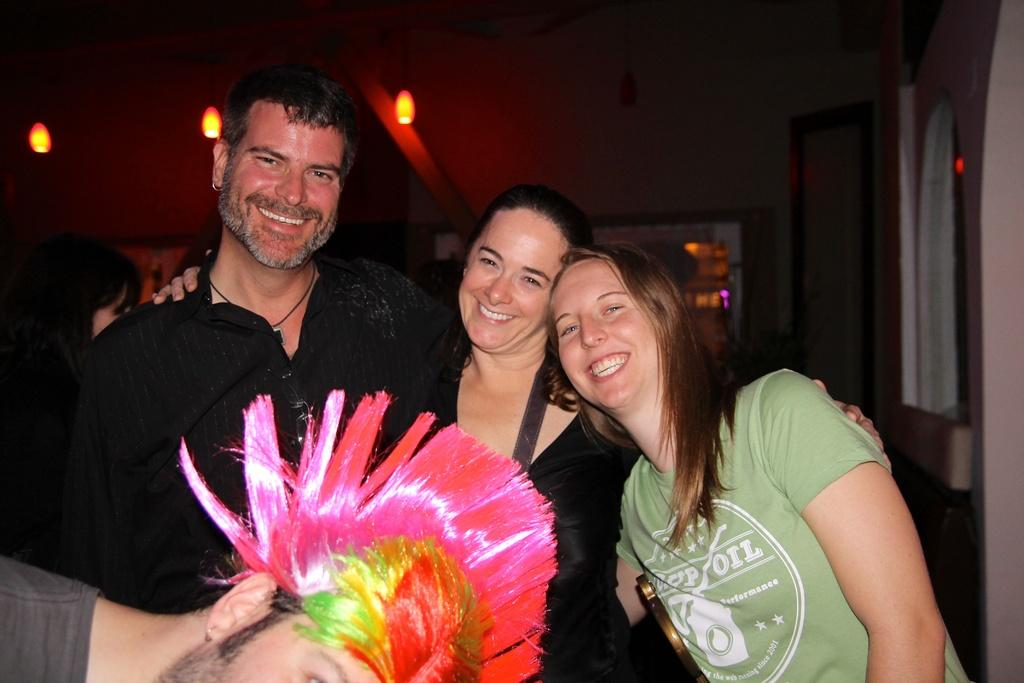What is happening in the middle of the image? There are persons in the middle of the image, and they are smiling. Can you describe the man at the bottom of the image? The man at the bottom of the image is wearing colorful hair. What can be seen in the background of the image? There are lights visible in the background of the image. What type of sticks are being used by the persons in the image? There is no indication of sticks being used by the persons in the image. Can you tell me where the park is located in the image? There is no park present in the image. 